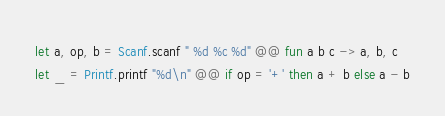Convert code to text. <code><loc_0><loc_0><loc_500><loc_500><_OCaml_>let a, op, b = Scanf.scanf " %d %c %d" @@ fun a b c -> a, b, c
let _ = Printf.printf "%d\n" @@ if op = '+' then a + b else a - b</code> 